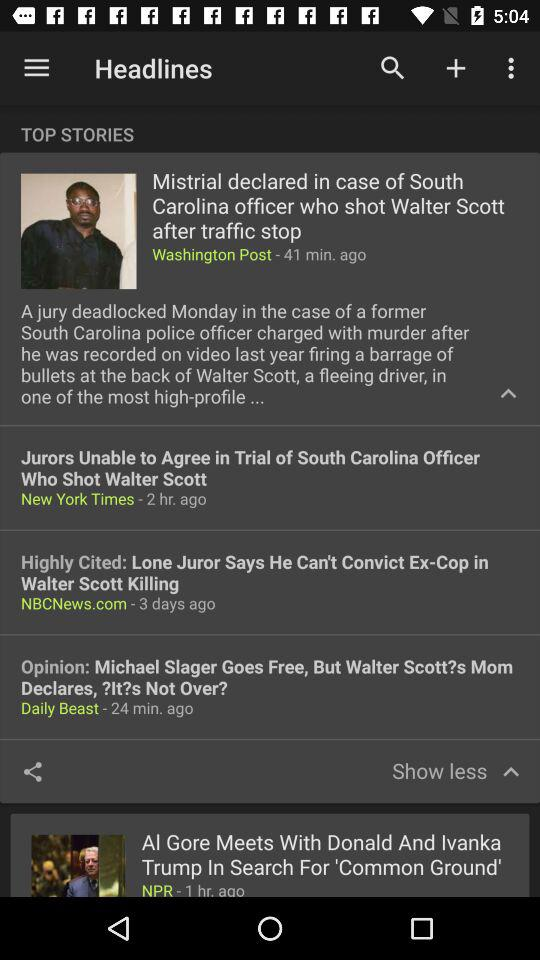What news was updated 41 minutes ago? The updated news was "Mistrial declared in case of South Carolina officer who shot Walter Scott after traffic stop". 